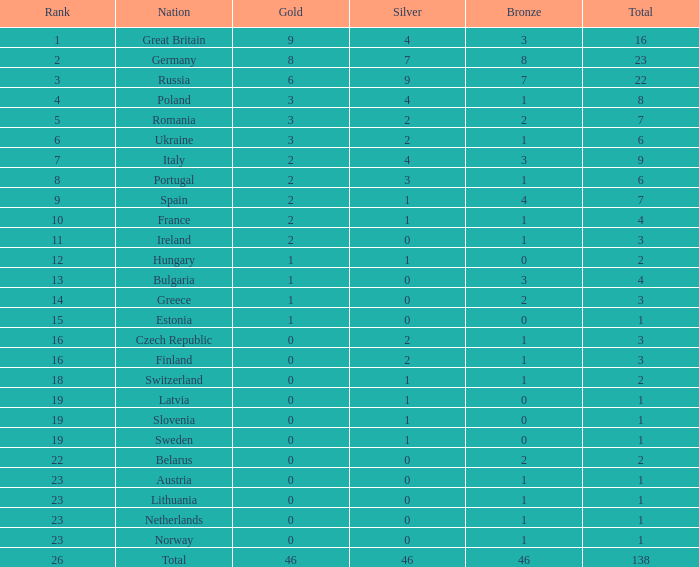For germany, when silver medals are greater than 2 and gold medals surpass 8, what can be the largest number of bronze medals? None. 